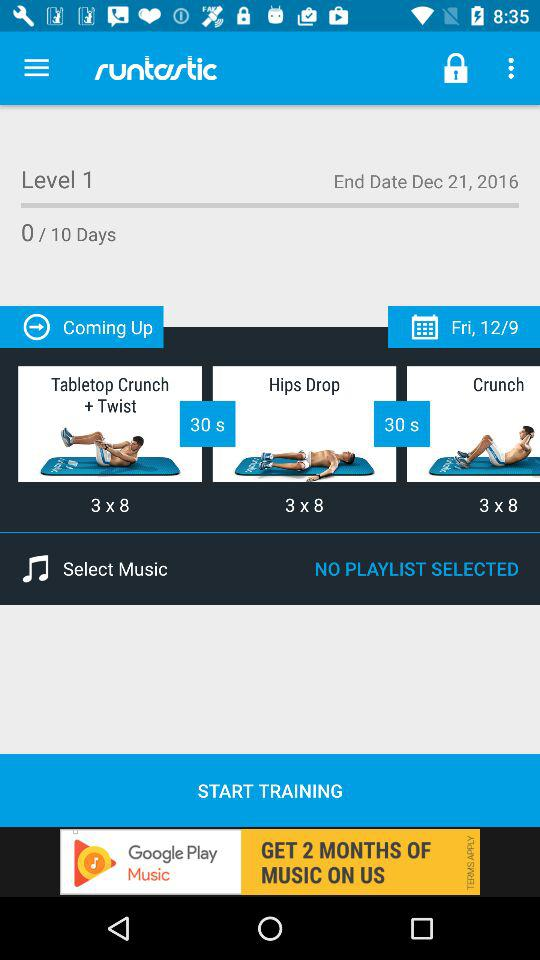What is the end date of level 1 training? The end date is December 21, 2016. 